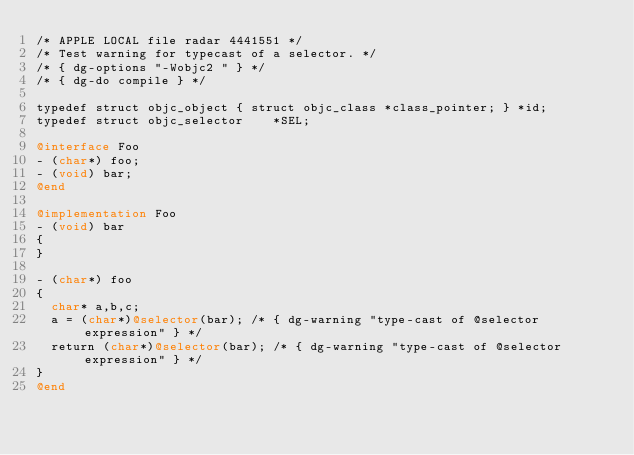Convert code to text. <code><loc_0><loc_0><loc_500><loc_500><_ObjectiveC_>/* APPLE LOCAL file radar 4441551 */
/* Test warning for typecast of a selector. */
/* { dg-options "-Wobjc2 " } */
/* { dg-do compile } */

typedef struct objc_object { struct objc_class *class_pointer; } *id;
typedef struct objc_selector    *SEL;

@interface Foo
- (char*) foo;
- (void) bar;
@end

@implementation Foo
- (void) bar
{
}

- (char*) foo
{
  char* a,b,c;
  a = (char*)@selector(bar); /* { dg-warning "type-cast of @selector expression" } */
  return (char*)@selector(bar); /* { dg-warning "type-cast of @selector expression" } */
}
@end

</code> 